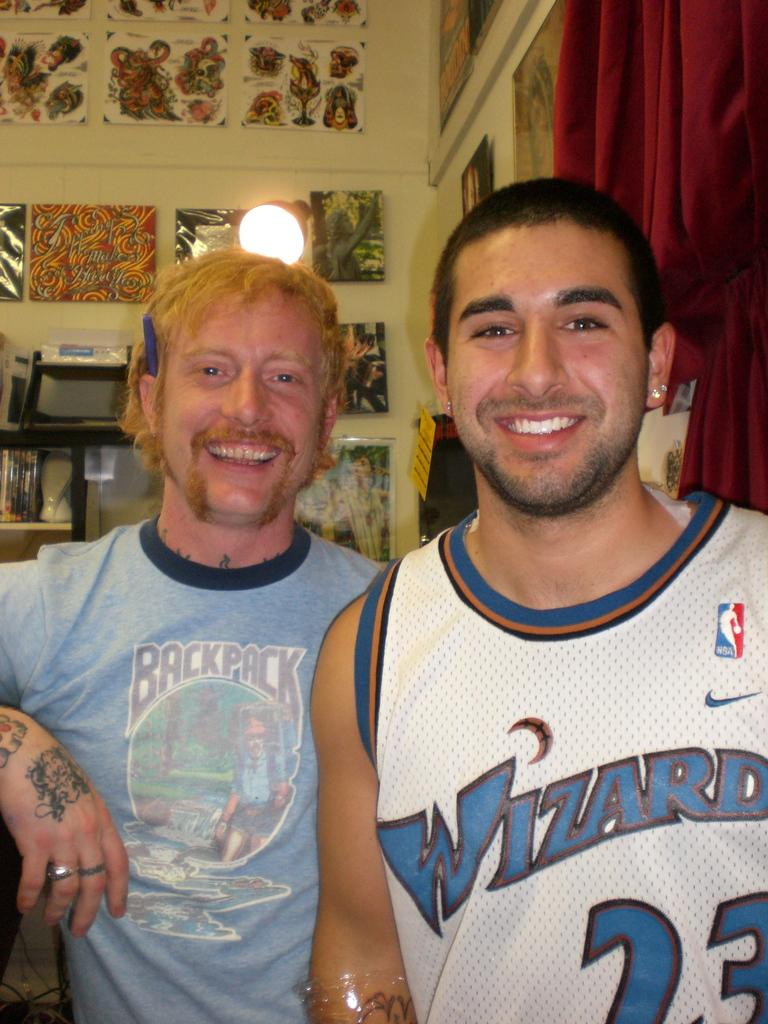Provide a one-sentence caption for the provided image. two men smiling for the camera with one wearing a wizard jersey. 